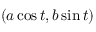<formula> <loc_0><loc_0><loc_500><loc_500>( a \cos t , b \sin t )</formula> 